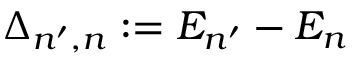<formula> <loc_0><loc_0><loc_500><loc_500>\Delta _ { n ^ { \prime } , n } \colon = E _ { n ^ { \prime } } - E _ { n }</formula> 